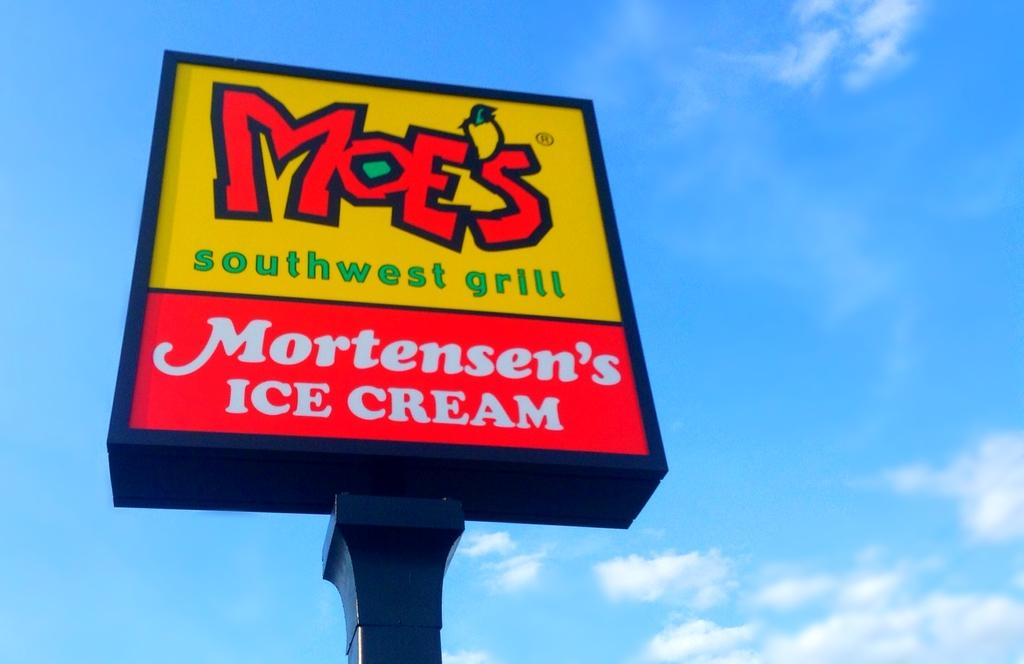<image>
Render a clear and concise summary of the photo. An advert for Moe's SouthWest grill and Mortensen's Ice Cream 